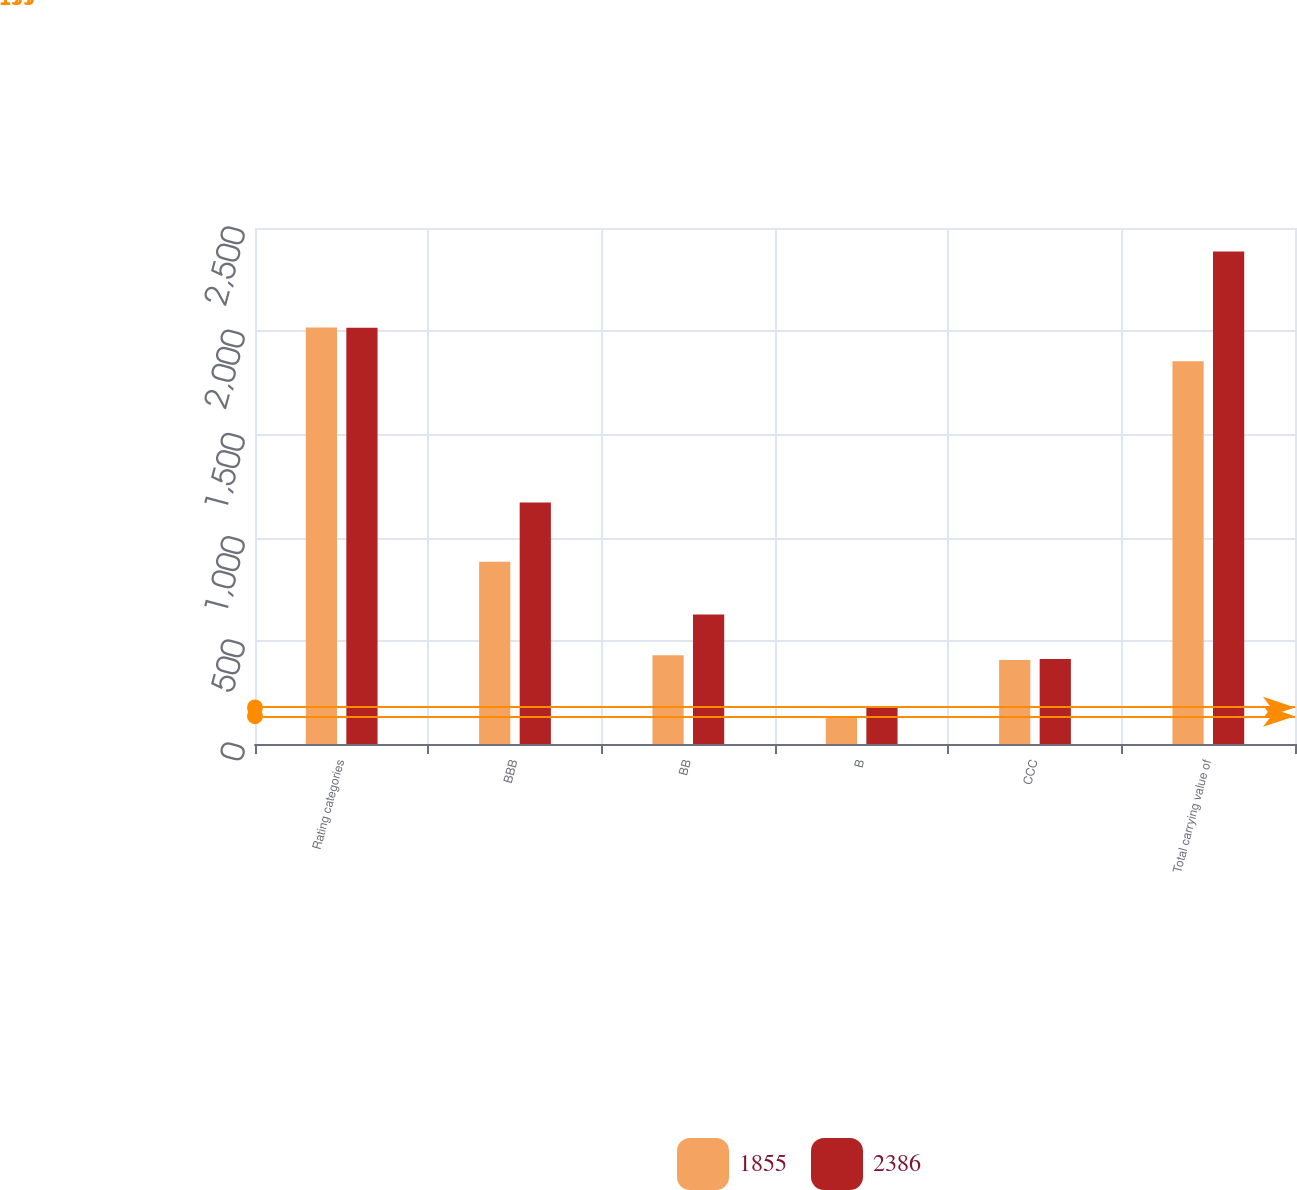<chart> <loc_0><loc_0><loc_500><loc_500><stacked_bar_chart><ecel><fcel>Rating categories<fcel>BBB<fcel>BB<fcel>B<fcel>CCC<fcel>Total carrying value of<nl><fcel>1855<fcel>2018<fcel>883<fcel>430<fcel>135<fcel>407<fcel>1855<nl><fcel>2386<fcel>2017<fcel>1170<fcel>627<fcel>177<fcel>412<fcel>2386<nl></chart> 